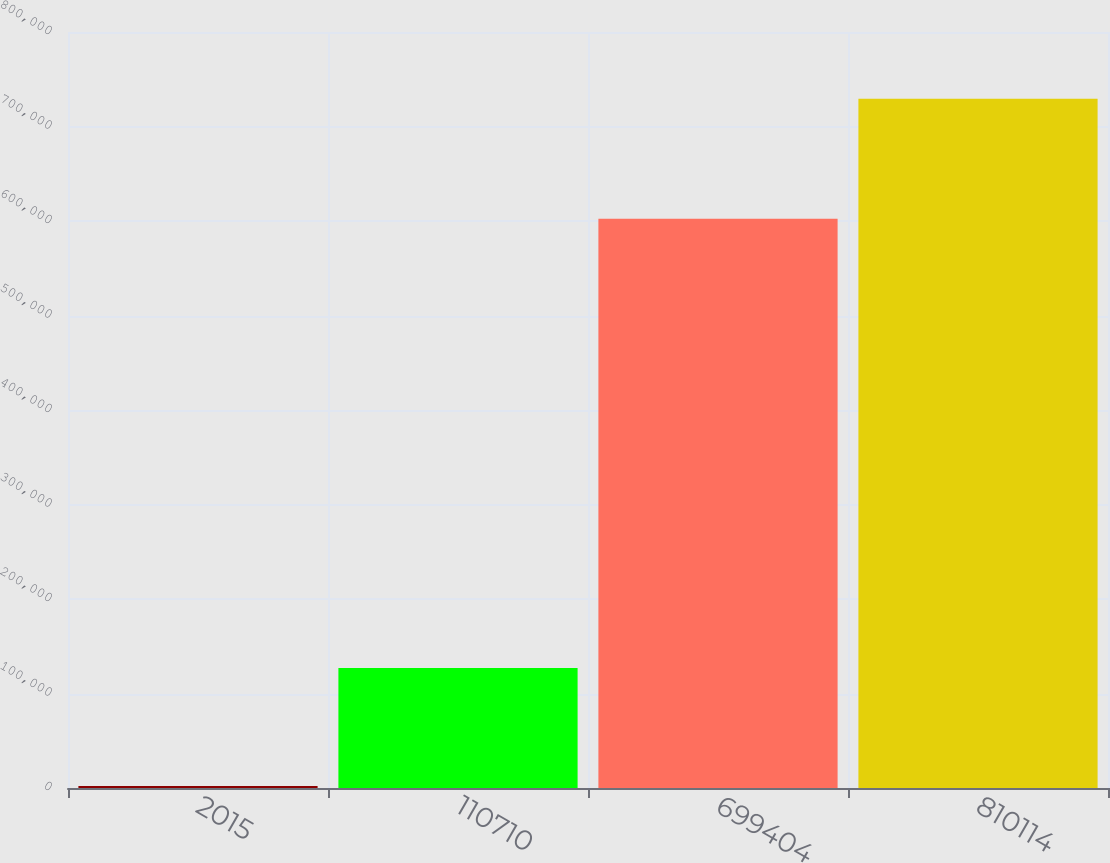<chart> <loc_0><loc_0><loc_500><loc_500><bar_chart><fcel>2015<fcel>110710<fcel>699404<fcel>810114<nl><fcel>2014<fcel>127084<fcel>602261<fcel>729345<nl></chart> 